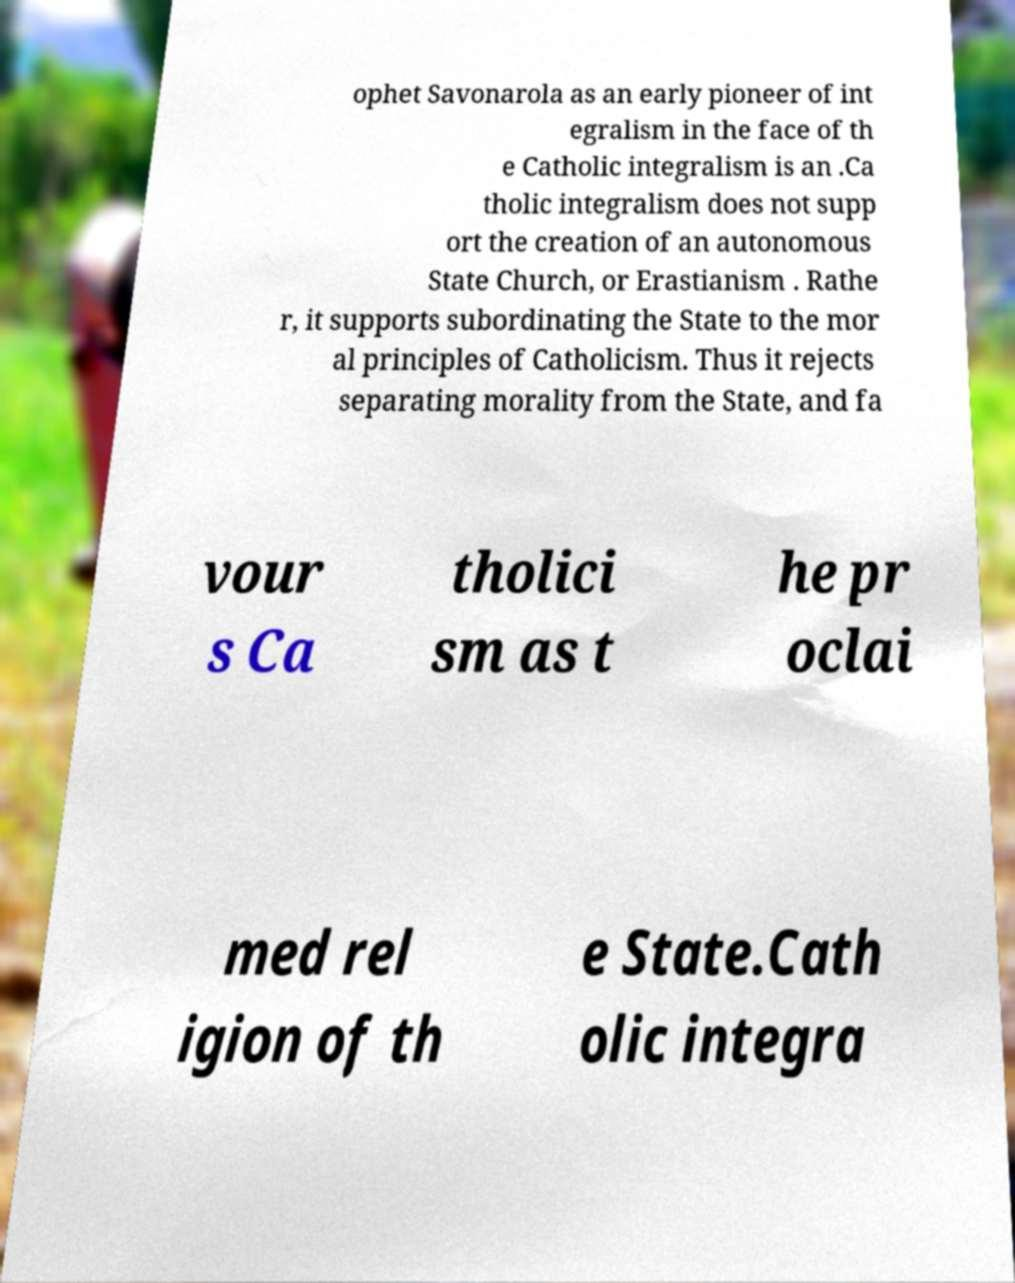I need the written content from this picture converted into text. Can you do that? ophet Savonarola as an early pioneer of int egralism in the face of th e Catholic integralism is an .Ca tholic integralism does not supp ort the creation of an autonomous State Church, or Erastianism . Rathe r, it supports subordinating the State to the mor al principles of Catholicism. Thus it rejects separating morality from the State, and fa vour s Ca tholici sm as t he pr oclai med rel igion of th e State.Cath olic integra 